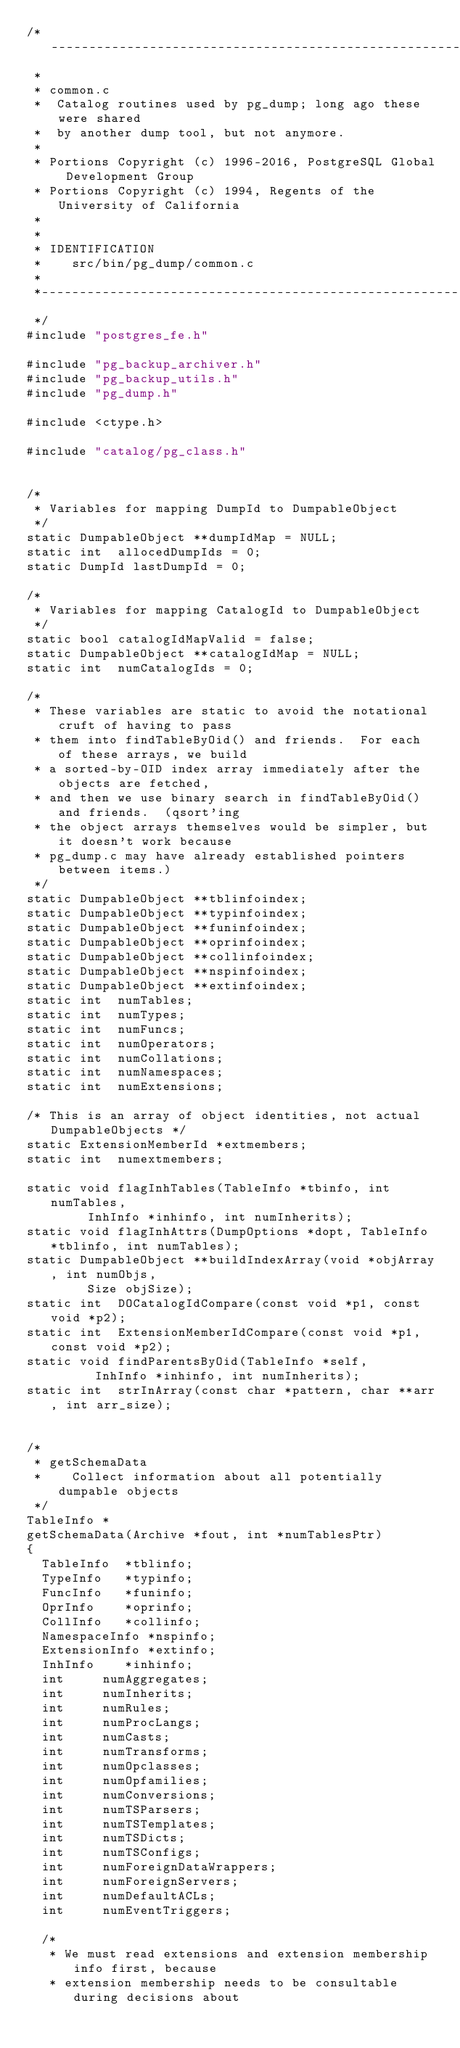<code> <loc_0><loc_0><loc_500><loc_500><_C_>/*-------------------------------------------------------------------------
 *
 * common.c
 *	Catalog routines used by pg_dump; long ago these were shared
 *	by another dump tool, but not anymore.
 *
 * Portions Copyright (c) 1996-2016, PostgreSQL Global Development Group
 * Portions Copyright (c) 1994, Regents of the University of California
 *
 *
 * IDENTIFICATION
 *	  src/bin/pg_dump/common.c
 *
 *-------------------------------------------------------------------------
 */
#include "postgres_fe.h"

#include "pg_backup_archiver.h"
#include "pg_backup_utils.h"
#include "pg_dump.h"

#include <ctype.h>

#include "catalog/pg_class.h"


/*
 * Variables for mapping DumpId to DumpableObject
 */
static DumpableObject **dumpIdMap = NULL;
static int	allocedDumpIds = 0;
static DumpId lastDumpId = 0;

/*
 * Variables for mapping CatalogId to DumpableObject
 */
static bool catalogIdMapValid = false;
static DumpableObject **catalogIdMap = NULL;
static int	numCatalogIds = 0;

/*
 * These variables are static to avoid the notational cruft of having to pass
 * them into findTableByOid() and friends.  For each of these arrays, we build
 * a sorted-by-OID index array immediately after the objects are fetched,
 * and then we use binary search in findTableByOid() and friends.  (qsort'ing
 * the object arrays themselves would be simpler, but it doesn't work because
 * pg_dump.c may have already established pointers between items.)
 */
static DumpableObject **tblinfoindex;
static DumpableObject **typinfoindex;
static DumpableObject **funinfoindex;
static DumpableObject **oprinfoindex;
static DumpableObject **collinfoindex;
static DumpableObject **nspinfoindex;
static DumpableObject **extinfoindex;
static int	numTables;
static int	numTypes;
static int	numFuncs;
static int	numOperators;
static int	numCollations;
static int	numNamespaces;
static int	numExtensions;

/* This is an array of object identities, not actual DumpableObjects */
static ExtensionMemberId *extmembers;
static int	numextmembers;

static void flagInhTables(TableInfo *tbinfo, int numTables,
			  InhInfo *inhinfo, int numInherits);
static void flagInhAttrs(DumpOptions *dopt, TableInfo *tblinfo, int numTables);
static DumpableObject **buildIndexArray(void *objArray, int numObjs,
				Size objSize);
static int	DOCatalogIdCompare(const void *p1, const void *p2);
static int	ExtensionMemberIdCompare(const void *p1, const void *p2);
static void findParentsByOid(TableInfo *self,
				 InhInfo *inhinfo, int numInherits);
static int	strInArray(const char *pattern, char **arr, int arr_size);


/*
 * getSchemaData
 *	  Collect information about all potentially dumpable objects
 */
TableInfo *
getSchemaData(Archive *fout, int *numTablesPtr)
{
	TableInfo  *tblinfo;
	TypeInfo   *typinfo;
	FuncInfo   *funinfo;
	OprInfo    *oprinfo;
	CollInfo   *collinfo;
	NamespaceInfo *nspinfo;
	ExtensionInfo *extinfo;
	InhInfo    *inhinfo;
	int			numAggregates;
	int			numInherits;
	int			numRules;
	int			numProcLangs;
	int			numCasts;
	int			numTransforms;
	int			numOpclasses;
	int			numOpfamilies;
	int			numConversions;
	int			numTSParsers;
	int			numTSTemplates;
	int			numTSDicts;
	int			numTSConfigs;
	int			numForeignDataWrappers;
	int			numForeignServers;
	int			numDefaultACLs;
	int			numEventTriggers;

	/*
	 * We must read extensions and extension membership info first, because
	 * extension membership needs to be consultable during decisions about</code> 